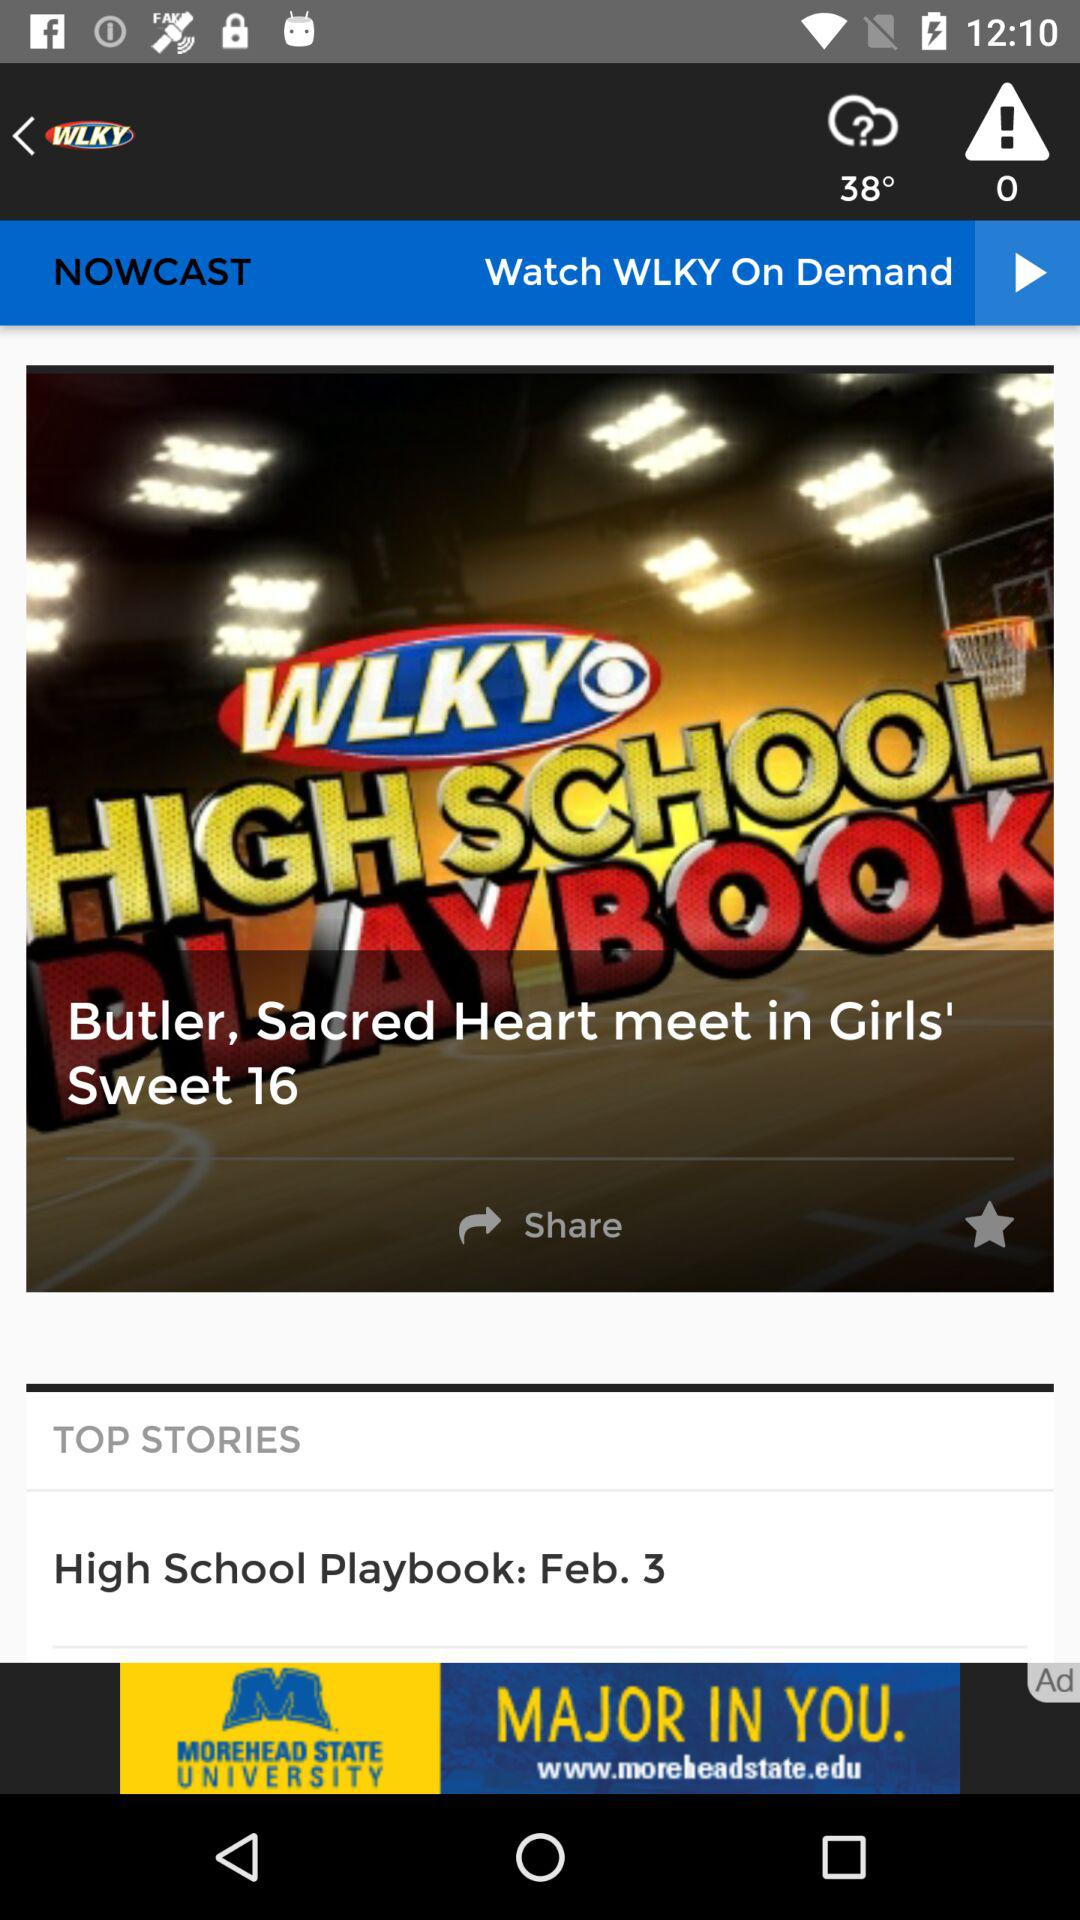What is the weather forecast?
When the provided information is insufficient, respond with <no answer>. <no answer> 